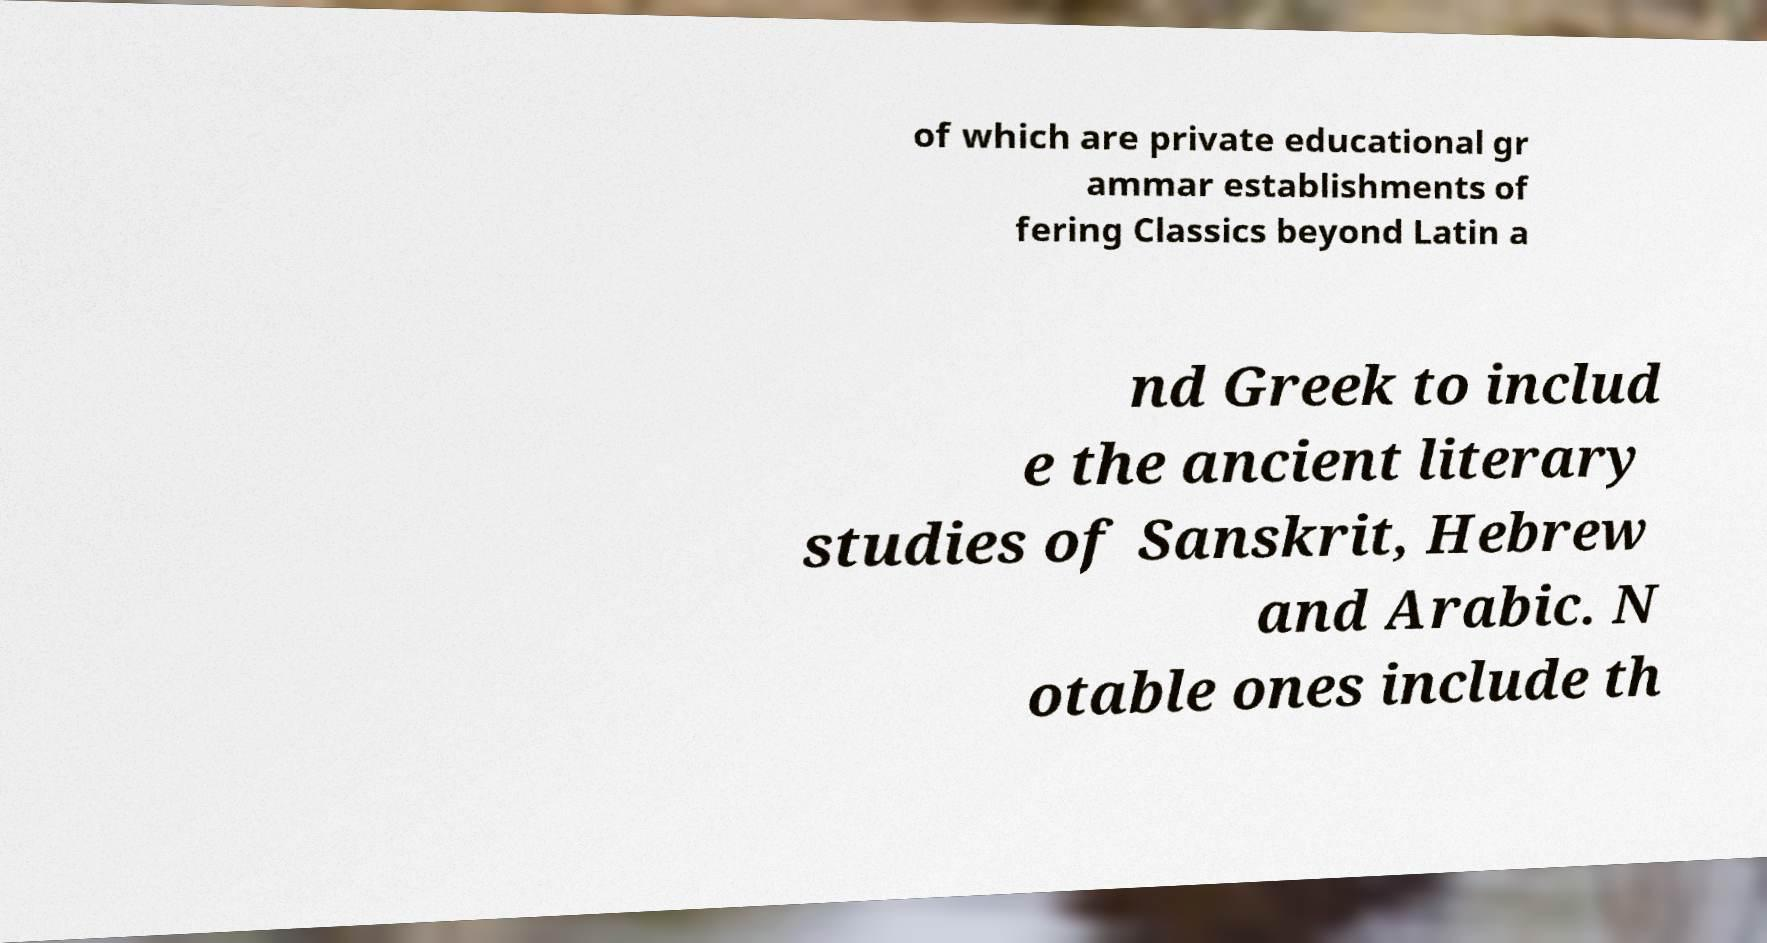Could you extract and type out the text from this image? of which are private educational gr ammar establishments of fering Classics beyond Latin a nd Greek to includ e the ancient literary studies of Sanskrit, Hebrew and Arabic. N otable ones include th 